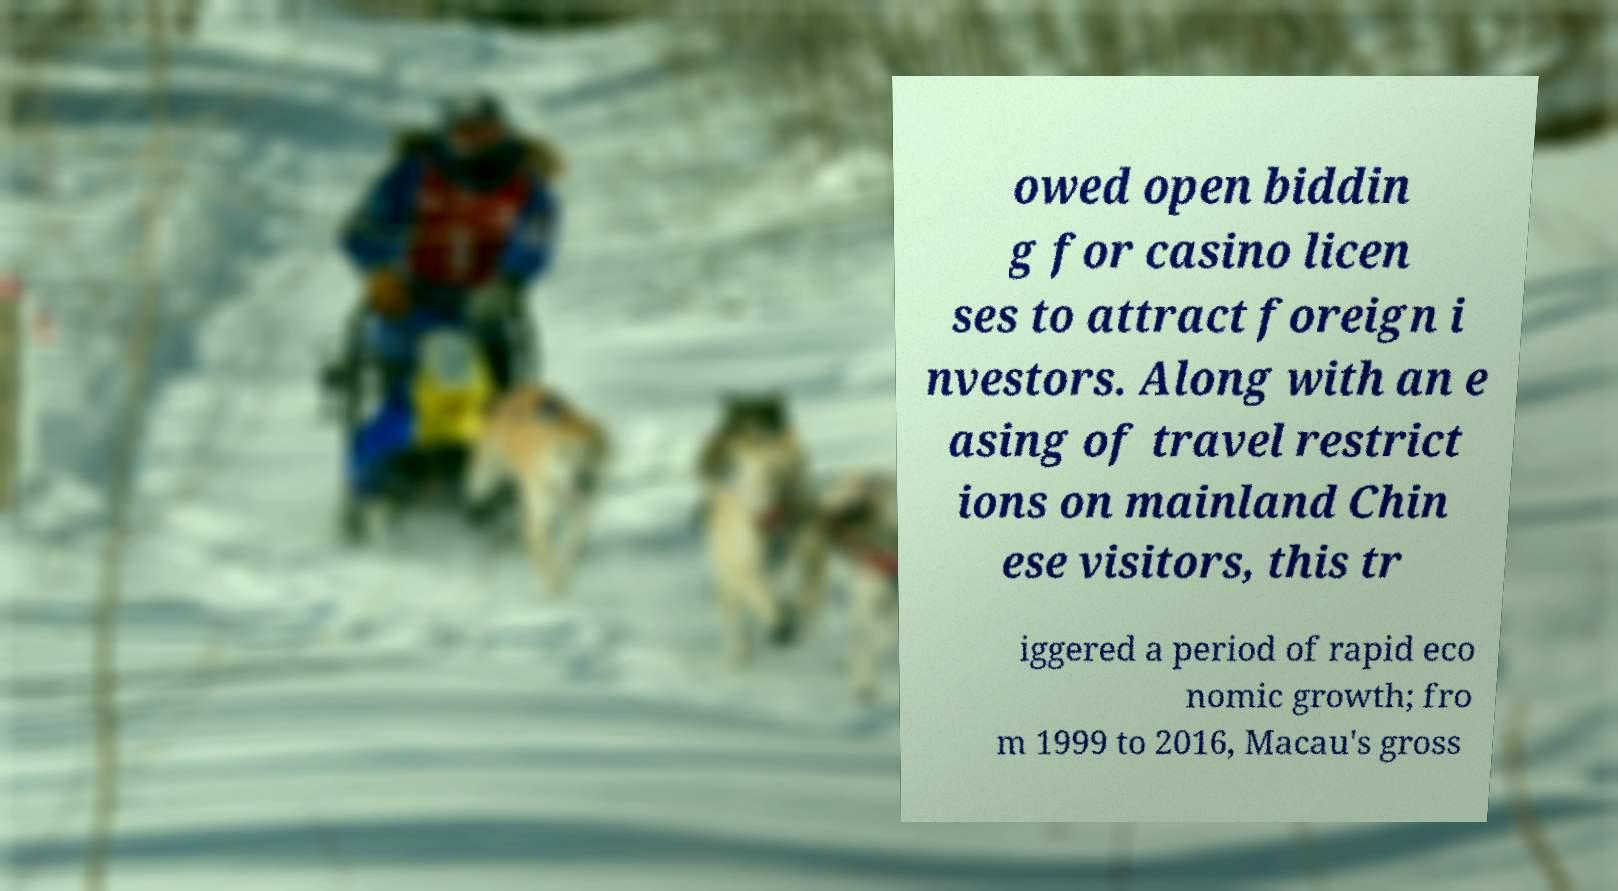Can you read and provide the text displayed in the image?This photo seems to have some interesting text. Can you extract and type it out for me? owed open biddin g for casino licen ses to attract foreign i nvestors. Along with an e asing of travel restrict ions on mainland Chin ese visitors, this tr iggered a period of rapid eco nomic growth; fro m 1999 to 2016, Macau's gross 